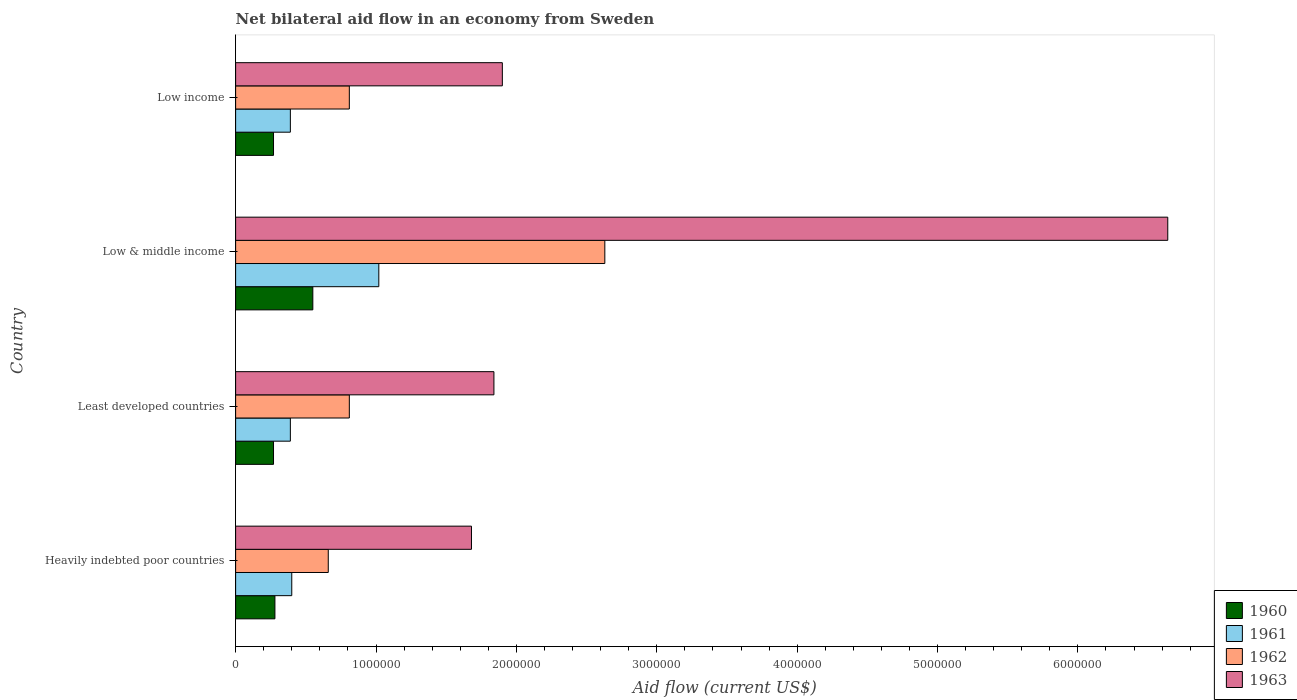How many different coloured bars are there?
Your answer should be very brief. 4. How many groups of bars are there?
Provide a succinct answer. 4. Are the number of bars on each tick of the Y-axis equal?
Your answer should be very brief. Yes. How many bars are there on the 1st tick from the top?
Give a very brief answer. 4. How many bars are there on the 1st tick from the bottom?
Keep it short and to the point. 4. Across all countries, what is the maximum net bilateral aid flow in 1963?
Your answer should be compact. 6.64e+06. In which country was the net bilateral aid flow in 1961 minimum?
Give a very brief answer. Least developed countries. What is the total net bilateral aid flow in 1962 in the graph?
Give a very brief answer. 4.91e+06. What is the average net bilateral aid flow in 1963 per country?
Provide a short and direct response. 3.02e+06. What is the difference between the net bilateral aid flow in 1962 and net bilateral aid flow in 1963 in Low & middle income?
Your response must be concise. -4.01e+06. In how many countries, is the net bilateral aid flow in 1963 greater than 5800000 US$?
Provide a short and direct response. 1. What is the ratio of the net bilateral aid flow in 1962 in Least developed countries to that in Low & middle income?
Make the answer very short. 0.31. What is the difference between the highest and the second highest net bilateral aid flow in 1961?
Your answer should be compact. 6.20e+05. What is the difference between the highest and the lowest net bilateral aid flow in 1962?
Provide a short and direct response. 1.97e+06. In how many countries, is the net bilateral aid flow in 1960 greater than the average net bilateral aid flow in 1960 taken over all countries?
Offer a terse response. 1. What does the 1st bar from the bottom in Heavily indebted poor countries represents?
Provide a short and direct response. 1960. How many bars are there?
Offer a very short reply. 16. What is the difference between two consecutive major ticks on the X-axis?
Offer a terse response. 1.00e+06. Are the values on the major ticks of X-axis written in scientific E-notation?
Your answer should be very brief. No. Does the graph contain any zero values?
Provide a short and direct response. No. Does the graph contain grids?
Provide a short and direct response. No. Where does the legend appear in the graph?
Your answer should be compact. Bottom right. How many legend labels are there?
Your response must be concise. 4. How are the legend labels stacked?
Your response must be concise. Vertical. What is the title of the graph?
Your response must be concise. Net bilateral aid flow in an economy from Sweden. What is the label or title of the X-axis?
Provide a succinct answer. Aid flow (current US$). What is the Aid flow (current US$) of 1963 in Heavily indebted poor countries?
Your answer should be compact. 1.68e+06. What is the Aid flow (current US$) of 1962 in Least developed countries?
Offer a terse response. 8.10e+05. What is the Aid flow (current US$) in 1963 in Least developed countries?
Offer a very short reply. 1.84e+06. What is the Aid flow (current US$) in 1961 in Low & middle income?
Give a very brief answer. 1.02e+06. What is the Aid flow (current US$) in 1962 in Low & middle income?
Keep it short and to the point. 2.63e+06. What is the Aid flow (current US$) in 1963 in Low & middle income?
Offer a very short reply. 6.64e+06. What is the Aid flow (current US$) of 1960 in Low income?
Offer a very short reply. 2.70e+05. What is the Aid flow (current US$) of 1961 in Low income?
Offer a terse response. 3.90e+05. What is the Aid flow (current US$) in 1962 in Low income?
Your response must be concise. 8.10e+05. What is the Aid flow (current US$) of 1963 in Low income?
Offer a terse response. 1.90e+06. Across all countries, what is the maximum Aid flow (current US$) of 1961?
Keep it short and to the point. 1.02e+06. Across all countries, what is the maximum Aid flow (current US$) of 1962?
Make the answer very short. 2.63e+06. Across all countries, what is the maximum Aid flow (current US$) in 1963?
Keep it short and to the point. 6.64e+06. Across all countries, what is the minimum Aid flow (current US$) in 1960?
Provide a short and direct response. 2.70e+05. Across all countries, what is the minimum Aid flow (current US$) of 1961?
Give a very brief answer. 3.90e+05. Across all countries, what is the minimum Aid flow (current US$) in 1963?
Keep it short and to the point. 1.68e+06. What is the total Aid flow (current US$) in 1960 in the graph?
Provide a succinct answer. 1.37e+06. What is the total Aid flow (current US$) of 1961 in the graph?
Provide a short and direct response. 2.20e+06. What is the total Aid flow (current US$) in 1962 in the graph?
Offer a very short reply. 4.91e+06. What is the total Aid flow (current US$) of 1963 in the graph?
Ensure brevity in your answer.  1.21e+07. What is the difference between the Aid flow (current US$) of 1963 in Heavily indebted poor countries and that in Least developed countries?
Offer a terse response. -1.60e+05. What is the difference between the Aid flow (current US$) of 1961 in Heavily indebted poor countries and that in Low & middle income?
Keep it short and to the point. -6.20e+05. What is the difference between the Aid flow (current US$) of 1962 in Heavily indebted poor countries and that in Low & middle income?
Keep it short and to the point. -1.97e+06. What is the difference between the Aid flow (current US$) in 1963 in Heavily indebted poor countries and that in Low & middle income?
Provide a short and direct response. -4.96e+06. What is the difference between the Aid flow (current US$) of 1960 in Heavily indebted poor countries and that in Low income?
Give a very brief answer. 10000. What is the difference between the Aid flow (current US$) of 1961 in Heavily indebted poor countries and that in Low income?
Offer a very short reply. 10000. What is the difference between the Aid flow (current US$) of 1962 in Heavily indebted poor countries and that in Low income?
Your response must be concise. -1.50e+05. What is the difference between the Aid flow (current US$) of 1963 in Heavily indebted poor countries and that in Low income?
Provide a short and direct response. -2.20e+05. What is the difference between the Aid flow (current US$) of 1960 in Least developed countries and that in Low & middle income?
Provide a succinct answer. -2.80e+05. What is the difference between the Aid flow (current US$) of 1961 in Least developed countries and that in Low & middle income?
Give a very brief answer. -6.30e+05. What is the difference between the Aid flow (current US$) of 1962 in Least developed countries and that in Low & middle income?
Offer a terse response. -1.82e+06. What is the difference between the Aid flow (current US$) of 1963 in Least developed countries and that in Low & middle income?
Provide a short and direct response. -4.80e+06. What is the difference between the Aid flow (current US$) in 1960 in Least developed countries and that in Low income?
Make the answer very short. 0. What is the difference between the Aid flow (current US$) of 1960 in Low & middle income and that in Low income?
Offer a very short reply. 2.80e+05. What is the difference between the Aid flow (current US$) in 1961 in Low & middle income and that in Low income?
Offer a very short reply. 6.30e+05. What is the difference between the Aid flow (current US$) in 1962 in Low & middle income and that in Low income?
Provide a succinct answer. 1.82e+06. What is the difference between the Aid flow (current US$) of 1963 in Low & middle income and that in Low income?
Ensure brevity in your answer.  4.74e+06. What is the difference between the Aid flow (current US$) in 1960 in Heavily indebted poor countries and the Aid flow (current US$) in 1962 in Least developed countries?
Your answer should be compact. -5.30e+05. What is the difference between the Aid flow (current US$) of 1960 in Heavily indebted poor countries and the Aid flow (current US$) of 1963 in Least developed countries?
Provide a succinct answer. -1.56e+06. What is the difference between the Aid flow (current US$) of 1961 in Heavily indebted poor countries and the Aid flow (current US$) of 1962 in Least developed countries?
Your response must be concise. -4.10e+05. What is the difference between the Aid flow (current US$) in 1961 in Heavily indebted poor countries and the Aid flow (current US$) in 1963 in Least developed countries?
Offer a terse response. -1.44e+06. What is the difference between the Aid flow (current US$) in 1962 in Heavily indebted poor countries and the Aid flow (current US$) in 1963 in Least developed countries?
Give a very brief answer. -1.18e+06. What is the difference between the Aid flow (current US$) in 1960 in Heavily indebted poor countries and the Aid flow (current US$) in 1961 in Low & middle income?
Make the answer very short. -7.40e+05. What is the difference between the Aid flow (current US$) of 1960 in Heavily indebted poor countries and the Aid flow (current US$) of 1962 in Low & middle income?
Provide a short and direct response. -2.35e+06. What is the difference between the Aid flow (current US$) of 1960 in Heavily indebted poor countries and the Aid flow (current US$) of 1963 in Low & middle income?
Provide a succinct answer. -6.36e+06. What is the difference between the Aid flow (current US$) in 1961 in Heavily indebted poor countries and the Aid flow (current US$) in 1962 in Low & middle income?
Ensure brevity in your answer.  -2.23e+06. What is the difference between the Aid flow (current US$) in 1961 in Heavily indebted poor countries and the Aid flow (current US$) in 1963 in Low & middle income?
Offer a very short reply. -6.24e+06. What is the difference between the Aid flow (current US$) of 1962 in Heavily indebted poor countries and the Aid flow (current US$) of 1963 in Low & middle income?
Your answer should be compact. -5.98e+06. What is the difference between the Aid flow (current US$) of 1960 in Heavily indebted poor countries and the Aid flow (current US$) of 1962 in Low income?
Offer a terse response. -5.30e+05. What is the difference between the Aid flow (current US$) in 1960 in Heavily indebted poor countries and the Aid flow (current US$) in 1963 in Low income?
Provide a succinct answer. -1.62e+06. What is the difference between the Aid flow (current US$) in 1961 in Heavily indebted poor countries and the Aid flow (current US$) in 1962 in Low income?
Give a very brief answer. -4.10e+05. What is the difference between the Aid flow (current US$) of 1961 in Heavily indebted poor countries and the Aid flow (current US$) of 1963 in Low income?
Your answer should be very brief. -1.50e+06. What is the difference between the Aid flow (current US$) of 1962 in Heavily indebted poor countries and the Aid flow (current US$) of 1963 in Low income?
Keep it short and to the point. -1.24e+06. What is the difference between the Aid flow (current US$) in 1960 in Least developed countries and the Aid flow (current US$) in 1961 in Low & middle income?
Keep it short and to the point. -7.50e+05. What is the difference between the Aid flow (current US$) in 1960 in Least developed countries and the Aid flow (current US$) in 1962 in Low & middle income?
Your response must be concise. -2.36e+06. What is the difference between the Aid flow (current US$) in 1960 in Least developed countries and the Aid flow (current US$) in 1963 in Low & middle income?
Your answer should be compact. -6.37e+06. What is the difference between the Aid flow (current US$) of 1961 in Least developed countries and the Aid flow (current US$) of 1962 in Low & middle income?
Provide a succinct answer. -2.24e+06. What is the difference between the Aid flow (current US$) of 1961 in Least developed countries and the Aid flow (current US$) of 1963 in Low & middle income?
Your answer should be very brief. -6.25e+06. What is the difference between the Aid flow (current US$) of 1962 in Least developed countries and the Aid flow (current US$) of 1963 in Low & middle income?
Give a very brief answer. -5.83e+06. What is the difference between the Aid flow (current US$) of 1960 in Least developed countries and the Aid flow (current US$) of 1961 in Low income?
Offer a terse response. -1.20e+05. What is the difference between the Aid flow (current US$) of 1960 in Least developed countries and the Aid flow (current US$) of 1962 in Low income?
Provide a short and direct response. -5.40e+05. What is the difference between the Aid flow (current US$) of 1960 in Least developed countries and the Aid flow (current US$) of 1963 in Low income?
Offer a very short reply. -1.63e+06. What is the difference between the Aid flow (current US$) in 1961 in Least developed countries and the Aid flow (current US$) in 1962 in Low income?
Your answer should be very brief. -4.20e+05. What is the difference between the Aid flow (current US$) of 1961 in Least developed countries and the Aid flow (current US$) of 1963 in Low income?
Ensure brevity in your answer.  -1.51e+06. What is the difference between the Aid flow (current US$) of 1962 in Least developed countries and the Aid flow (current US$) of 1963 in Low income?
Your answer should be very brief. -1.09e+06. What is the difference between the Aid flow (current US$) in 1960 in Low & middle income and the Aid flow (current US$) in 1962 in Low income?
Offer a terse response. -2.60e+05. What is the difference between the Aid flow (current US$) of 1960 in Low & middle income and the Aid flow (current US$) of 1963 in Low income?
Offer a terse response. -1.35e+06. What is the difference between the Aid flow (current US$) in 1961 in Low & middle income and the Aid flow (current US$) in 1962 in Low income?
Your answer should be compact. 2.10e+05. What is the difference between the Aid flow (current US$) in 1961 in Low & middle income and the Aid flow (current US$) in 1963 in Low income?
Your answer should be compact. -8.80e+05. What is the difference between the Aid flow (current US$) in 1962 in Low & middle income and the Aid flow (current US$) in 1963 in Low income?
Keep it short and to the point. 7.30e+05. What is the average Aid flow (current US$) in 1960 per country?
Make the answer very short. 3.42e+05. What is the average Aid flow (current US$) of 1962 per country?
Provide a short and direct response. 1.23e+06. What is the average Aid flow (current US$) in 1963 per country?
Provide a short and direct response. 3.02e+06. What is the difference between the Aid flow (current US$) of 1960 and Aid flow (current US$) of 1961 in Heavily indebted poor countries?
Provide a succinct answer. -1.20e+05. What is the difference between the Aid flow (current US$) in 1960 and Aid flow (current US$) in 1962 in Heavily indebted poor countries?
Your answer should be very brief. -3.80e+05. What is the difference between the Aid flow (current US$) in 1960 and Aid flow (current US$) in 1963 in Heavily indebted poor countries?
Keep it short and to the point. -1.40e+06. What is the difference between the Aid flow (current US$) of 1961 and Aid flow (current US$) of 1962 in Heavily indebted poor countries?
Make the answer very short. -2.60e+05. What is the difference between the Aid flow (current US$) of 1961 and Aid flow (current US$) of 1963 in Heavily indebted poor countries?
Provide a short and direct response. -1.28e+06. What is the difference between the Aid flow (current US$) in 1962 and Aid flow (current US$) in 1963 in Heavily indebted poor countries?
Provide a succinct answer. -1.02e+06. What is the difference between the Aid flow (current US$) in 1960 and Aid flow (current US$) in 1962 in Least developed countries?
Provide a short and direct response. -5.40e+05. What is the difference between the Aid flow (current US$) of 1960 and Aid flow (current US$) of 1963 in Least developed countries?
Make the answer very short. -1.57e+06. What is the difference between the Aid flow (current US$) in 1961 and Aid flow (current US$) in 1962 in Least developed countries?
Keep it short and to the point. -4.20e+05. What is the difference between the Aid flow (current US$) of 1961 and Aid flow (current US$) of 1963 in Least developed countries?
Ensure brevity in your answer.  -1.45e+06. What is the difference between the Aid flow (current US$) in 1962 and Aid flow (current US$) in 1963 in Least developed countries?
Keep it short and to the point. -1.03e+06. What is the difference between the Aid flow (current US$) in 1960 and Aid flow (current US$) in 1961 in Low & middle income?
Give a very brief answer. -4.70e+05. What is the difference between the Aid flow (current US$) of 1960 and Aid flow (current US$) of 1962 in Low & middle income?
Make the answer very short. -2.08e+06. What is the difference between the Aid flow (current US$) of 1960 and Aid flow (current US$) of 1963 in Low & middle income?
Give a very brief answer. -6.09e+06. What is the difference between the Aid flow (current US$) in 1961 and Aid flow (current US$) in 1962 in Low & middle income?
Provide a succinct answer. -1.61e+06. What is the difference between the Aid flow (current US$) in 1961 and Aid flow (current US$) in 1963 in Low & middle income?
Your answer should be very brief. -5.62e+06. What is the difference between the Aid flow (current US$) in 1962 and Aid flow (current US$) in 1963 in Low & middle income?
Make the answer very short. -4.01e+06. What is the difference between the Aid flow (current US$) of 1960 and Aid flow (current US$) of 1961 in Low income?
Your answer should be very brief. -1.20e+05. What is the difference between the Aid flow (current US$) of 1960 and Aid flow (current US$) of 1962 in Low income?
Offer a terse response. -5.40e+05. What is the difference between the Aid flow (current US$) of 1960 and Aid flow (current US$) of 1963 in Low income?
Ensure brevity in your answer.  -1.63e+06. What is the difference between the Aid flow (current US$) in 1961 and Aid flow (current US$) in 1962 in Low income?
Provide a succinct answer. -4.20e+05. What is the difference between the Aid flow (current US$) of 1961 and Aid flow (current US$) of 1963 in Low income?
Make the answer very short. -1.51e+06. What is the difference between the Aid flow (current US$) in 1962 and Aid flow (current US$) in 1963 in Low income?
Give a very brief answer. -1.09e+06. What is the ratio of the Aid flow (current US$) of 1961 in Heavily indebted poor countries to that in Least developed countries?
Offer a terse response. 1.03. What is the ratio of the Aid flow (current US$) of 1962 in Heavily indebted poor countries to that in Least developed countries?
Keep it short and to the point. 0.81. What is the ratio of the Aid flow (current US$) of 1960 in Heavily indebted poor countries to that in Low & middle income?
Keep it short and to the point. 0.51. What is the ratio of the Aid flow (current US$) of 1961 in Heavily indebted poor countries to that in Low & middle income?
Your answer should be very brief. 0.39. What is the ratio of the Aid flow (current US$) in 1962 in Heavily indebted poor countries to that in Low & middle income?
Offer a terse response. 0.25. What is the ratio of the Aid flow (current US$) of 1963 in Heavily indebted poor countries to that in Low & middle income?
Offer a terse response. 0.25. What is the ratio of the Aid flow (current US$) of 1960 in Heavily indebted poor countries to that in Low income?
Your answer should be compact. 1.04. What is the ratio of the Aid flow (current US$) in 1961 in Heavily indebted poor countries to that in Low income?
Offer a terse response. 1.03. What is the ratio of the Aid flow (current US$) in 1962 in Heavily indebted poor countries to that in Low income?
Your response must be concise. 0.81. What is the ratio of the Aid flow (current US$) of 1963 in Heavily indebted poor countries to that in Low income?
Ensure brevity in your answer.  0.88. What is the ratio of the Aid flow (current US$) of 1960 in Least developed countries to that in Low & middle income?
Give a very brief answer. 0.49. What is the ratio of the Aid flow (current US$) in 1961 in Least developed countries to that in Low & middle income?
Keep it short and to the point. 0.38. What is the ratio of the Aid flow (current US$) of 1962 in Least developed countries to that in Low & middle income?
Make the answer very short. 0.31. What is the ratio of the Aid flow (current US$) of 1963 in Least developed countries to that in Low & middle income?
Your answer should be very brief. 0.28. What is the ratio of the Aid flow (current US$) in 1961 in Least developed countries to that in Low income?
Make the answer very short. 1. What is the ratio of the Aid flow (current US$) in 1962 in Least developed countries to that in Low income?
Make the answer very short. 1. What is the ratio of the Aid flow (current US$) of 1963 in Least developed countries to that in Low income?
Your answer should be compact. 0.97. What is the ratio of the Aid flow (current US$) of 1960 in Low & middle income to that in Low income?
Keep it short and to the point. 2.04. What is the ratio of the Aid flow (current US$) in 1961 in Low & middle income to that in Low income?
Provide a succinct answer. 2.62. What is the ratio of the Aid flow (current US$) of 1962 in Low & middle income to that in Low income?
Your answer should be compact. 3.25. What is the ratio of the Aid flow (current US$) of 1963 in Low & middle income to that in Low income?
Make the answer very short. 3.49. What is the difference between the highest and the second highest Aid flow (current US$) in 1960?
Give a very brief answer. 2.70e+05. What is the difference between the highest and the second highest Aid flow (current US$) in 1961?
Provide a succinct answer. 6.20e+05. What is the difference between the highest and the second highest Aid flow (current US$) in 1962?
Your response must be concise. 1.82e+06. What is the difference between the highest and the second highest Aid flow (current US$) of 1963?
Offer a terse response. 4.74e+06. What is the difference between the highest and the lowest Aid flow (current US$) in 1961?
Ensure brevity in your answer.  6.30e+05. What is the difference between the highest and the lowest Aid flow (current US$) of 1962?
Offer a terse response. 1.97e+06. What is the difference between the highest and the lowest Aid flow (current US$) of 1963?
Make the answer very short. 4.96e+06. 